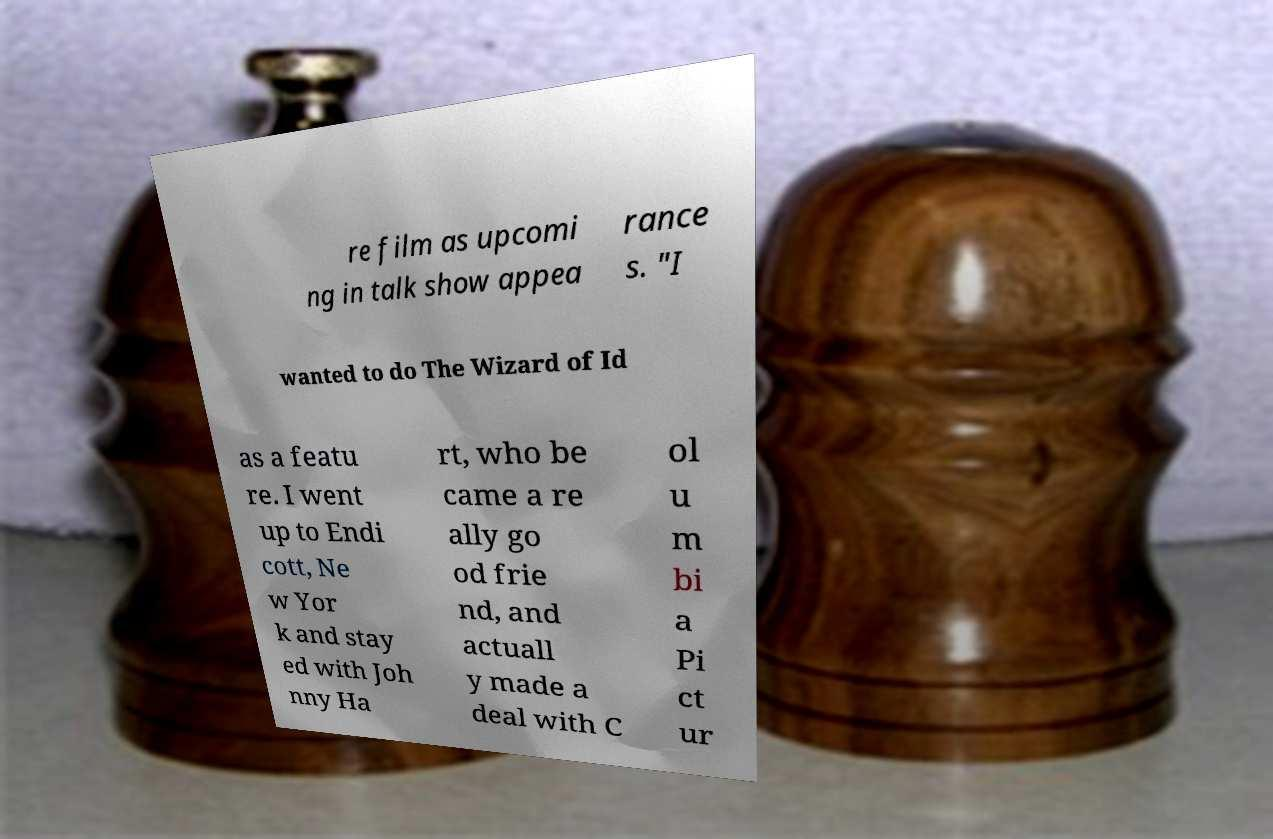There's text embedded in this image that I need extracted. Can you transcribe it verbatim? re film as upcomi ng in talk show appea rance s. "I wanted to do The Wizard of Id as a featu re. I went up to Endi cott, Ne w Yor k and stay ed with Joh nny Ha rt, who be came a re ally go od frie nd, and actuall y made a deal with C ol u m bi a Pi ct ur 